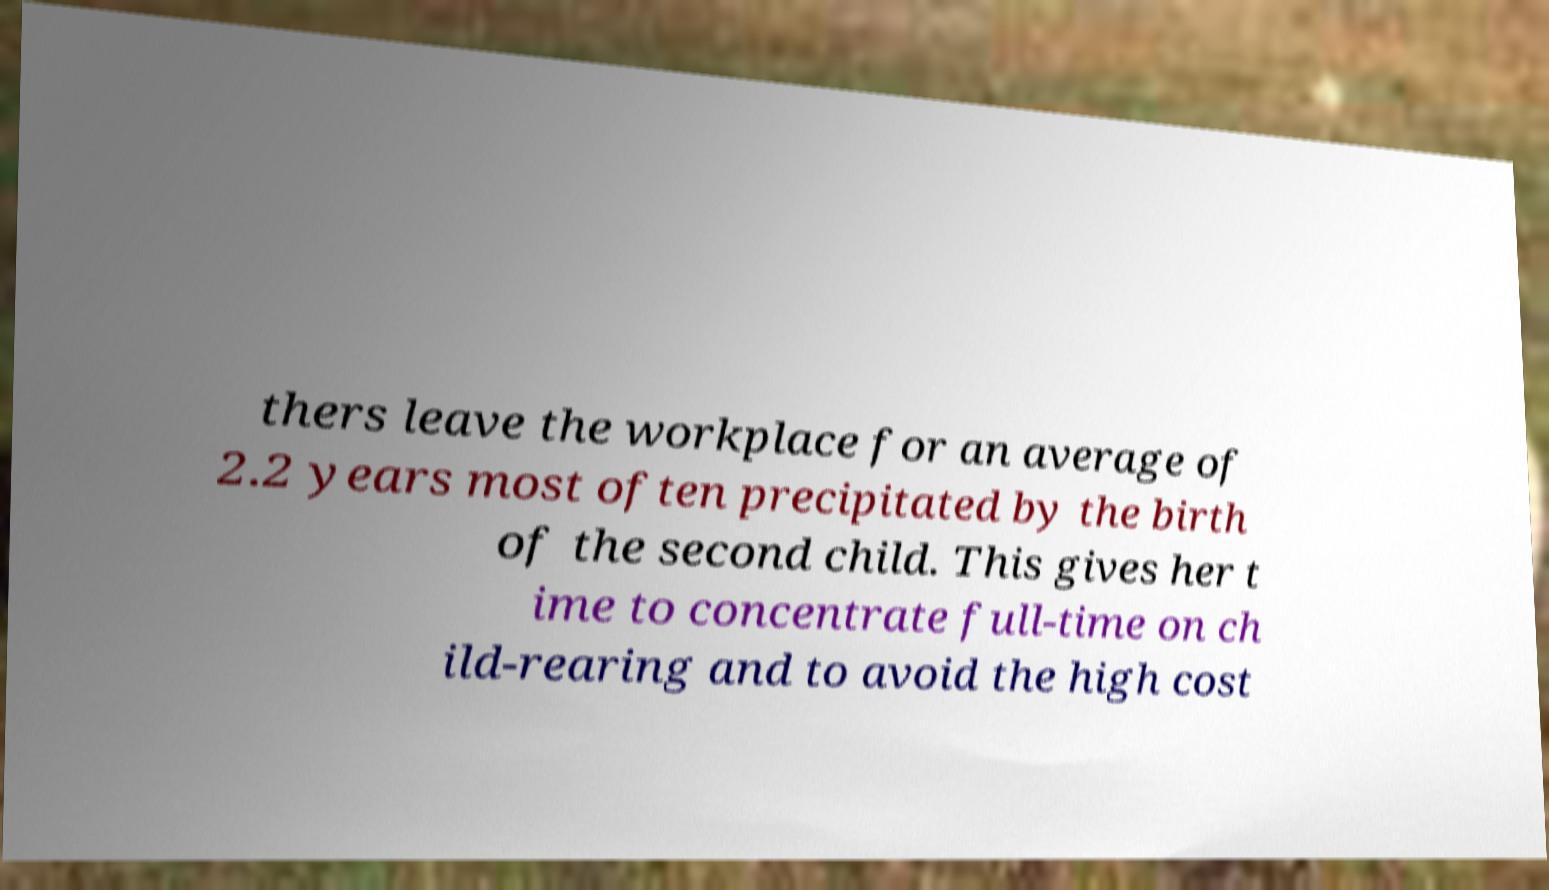Please read and relay the text visible in this image. What does it say? thers leave the workplace for an average of 2.2 years most often precipitated by the birth of the second child. This gives her t ime to concentrate full-time on ch ild-rearing and to avoid the high cost 